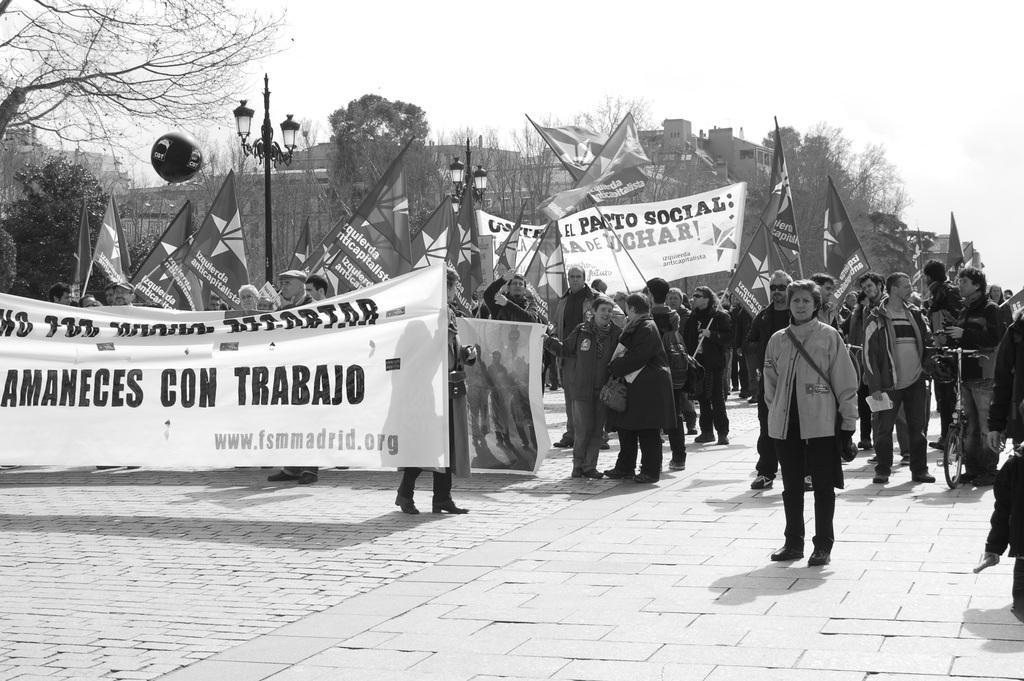Can you describe this image briefly? In this image we can see a group of people standing and holding a banner with some written text, near that we can see street lights, behind we can see the buildings. And we can see the trees and dried trees, we can see the sky in the background, at the bottom we can see the floor. 